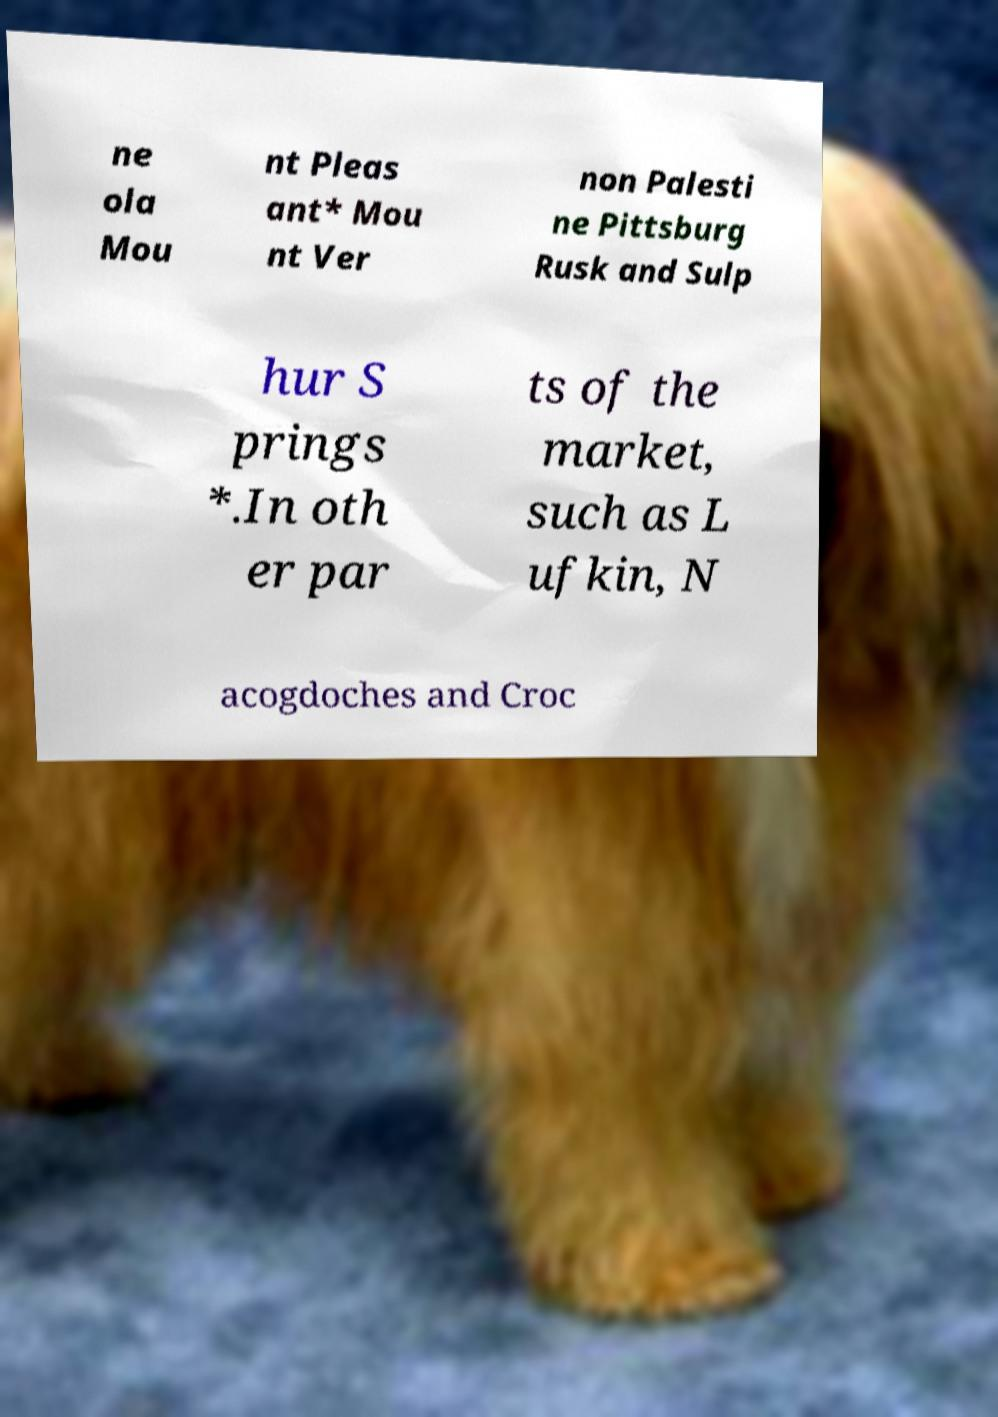I need the written content from this picture converted into text. Can you do that? ne ola Mou nt Pleas ant* Mou nt Ver non Palesti ne Pittsburg Rusk and Sulp hur S prings *.In oth er par ts of the market, such as L ufkin, N acogdoches and Croc 